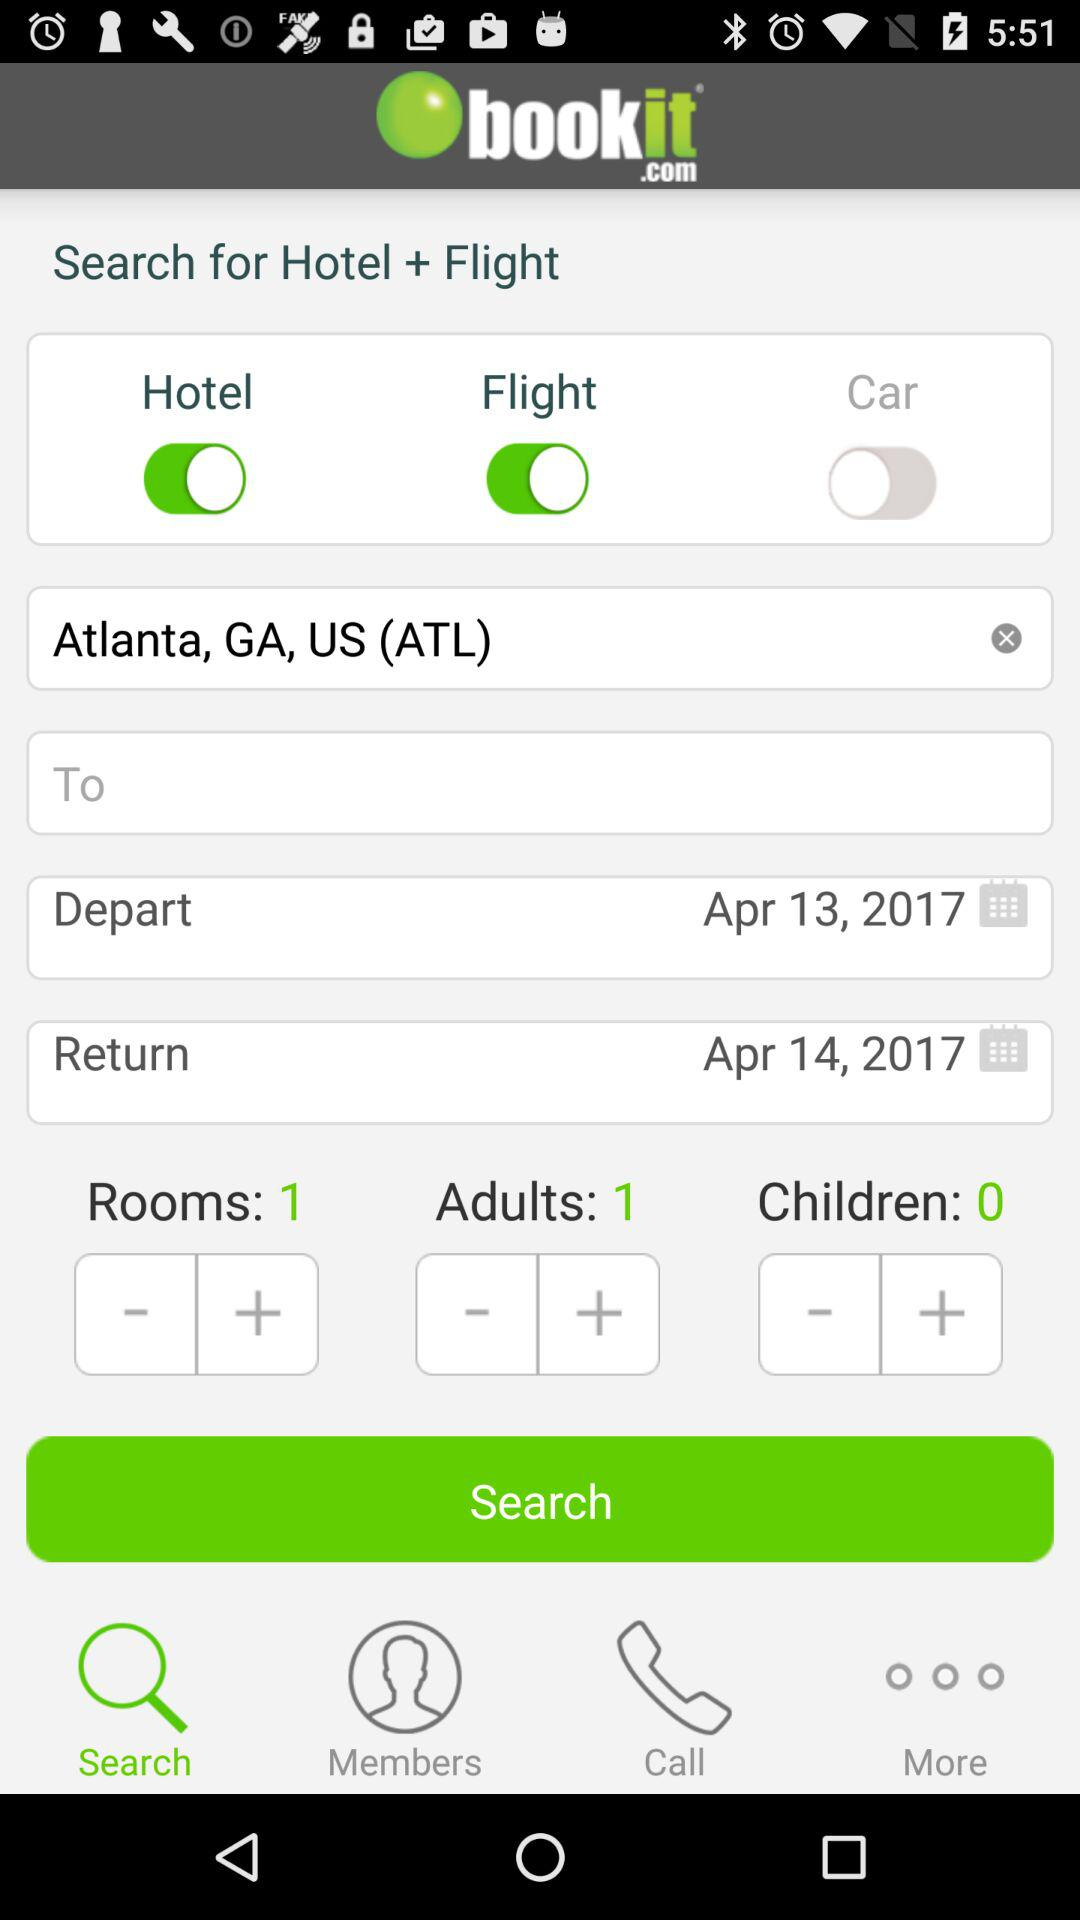What's the departure date? The departure date is April 13, 2017. 